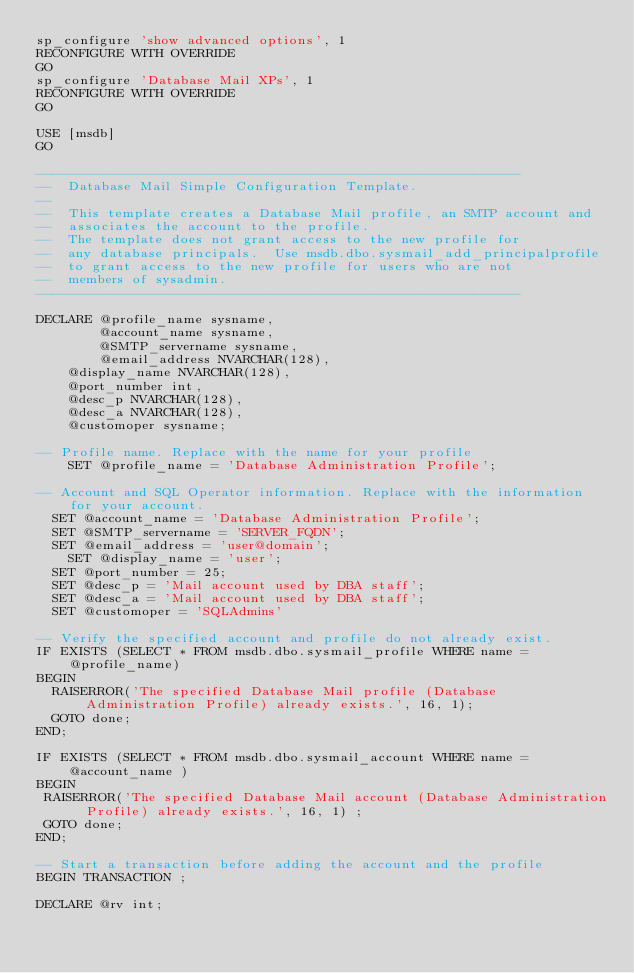<code> <loc_0><loc_0><loc_500><loc_500><_SQL_>sp_configure 'show advanced options', 1
RECONFIGURE WITH OVERRIDE
GO
sp_configure 'Database Mail XPs', 1
RECONFIGURE WITH OVERRIDE
GO

USE [msdb]
GO

-------------------------------------------------------------
--  Database Mail Simple Configuration Template.
--
--  This template creates a Database Mail profile, an SMTP account and
--  associates the account to the profile.
--  The template does not grant access to the new profile for
--  any database principals.  Use msdb.dbo.sysmail_add_principalprofile
--  to grant access to the new profile for users who are not
--  members of sysadmin.
-------------------------------------------------------------

DECLARE @profile_name sysname,
        @account_name sysname,
        @SMTP_servername sysname,
        @email_address NVARCHAR(128),
		@display_name NVARCHAR(128),
		@port_number int,
		@desc_p NVARCHAR(128),
		@desc_a NVARCHAR(128),
		@customoper sysname;

-- Profile name. Replace with the name for your profile
    SET @profile_name = 'Database Administration Profile';

-- Account and SQL Operator information. Replace with the information for your account.
	SET @account_name = 'Database Administration Profile';
	SET @SMTP_servername = 'SERVER_FQDN';
	SET @email_address = 'user@domain';
    SET @display_name = 'user';
	SET @port_number = 25;
	SET @desc_p = 'Mail account used by DBA staff';
	SET @desc_a = 'Mail account used by DBA staff';
	SET @customoper = 'SQLAdmins'

-- Verify the specified account and profile do not already exist.
IF EXISTS (SELECT * FROM msdb.dbo.sysmail_profile WHERE name = @profile_name)
BEGIN
  RAISERROR('The specified Database Mail profile (Database Administration Profile) already exists.', 16, 1);
  GOTO done;
END;

IF EXISTS (SELECT * FROM msdb.dbo.sysmail_account WHERE name = @account_name )
BEGIN
 RAISERROR('The specified Database Mail account (Database Administration Profile) already exists.', 16, 1) ;
 GOTO done;
END;

-- Start a transaction before adding the account and the profile
BEGIN TRANSACTION ;

DECLARE @rv int;
</code> 